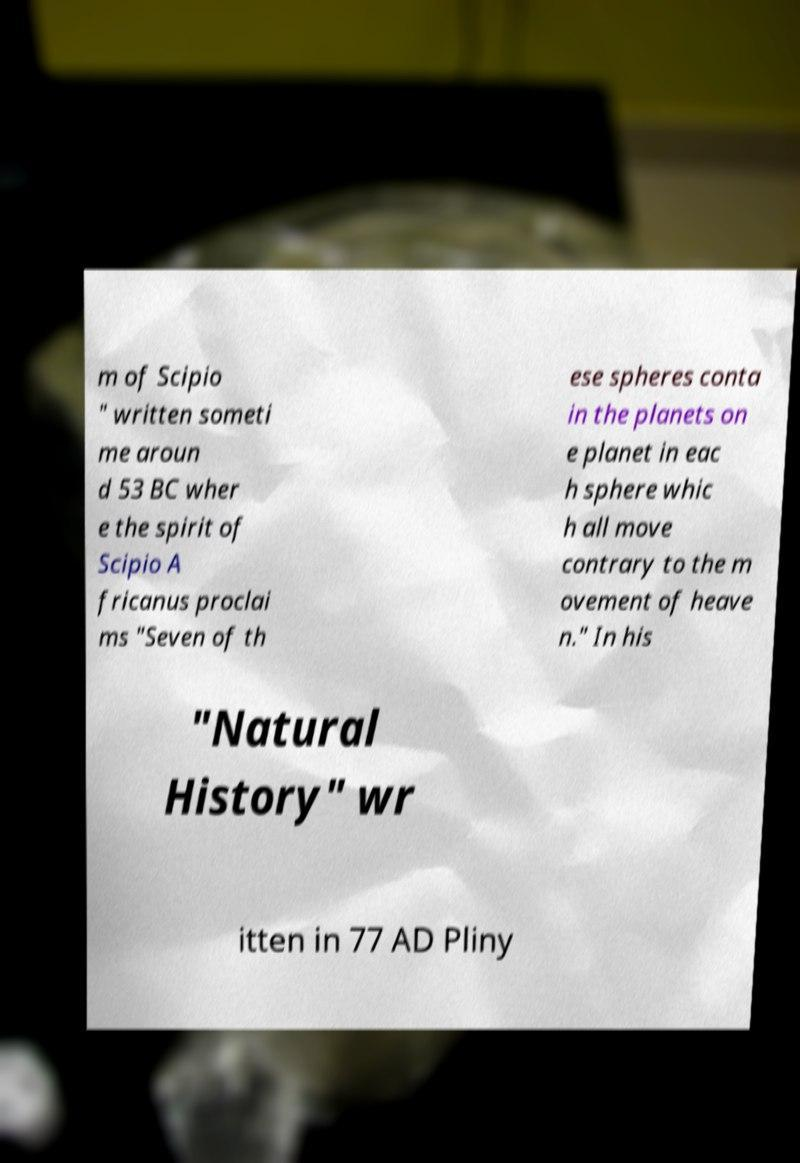Please identify and transcribe the text found in this image. m of Scipio " written someti me aroun d 53 BC wher e the spirit of Scipio A fricanus proclai ms "Seven of th ese spheres conta in the planets on e planet in eac h sphere whic h all move contrary to the m ovement of heave n." In his "Natural History" wr itten in 77 AD Pliny 